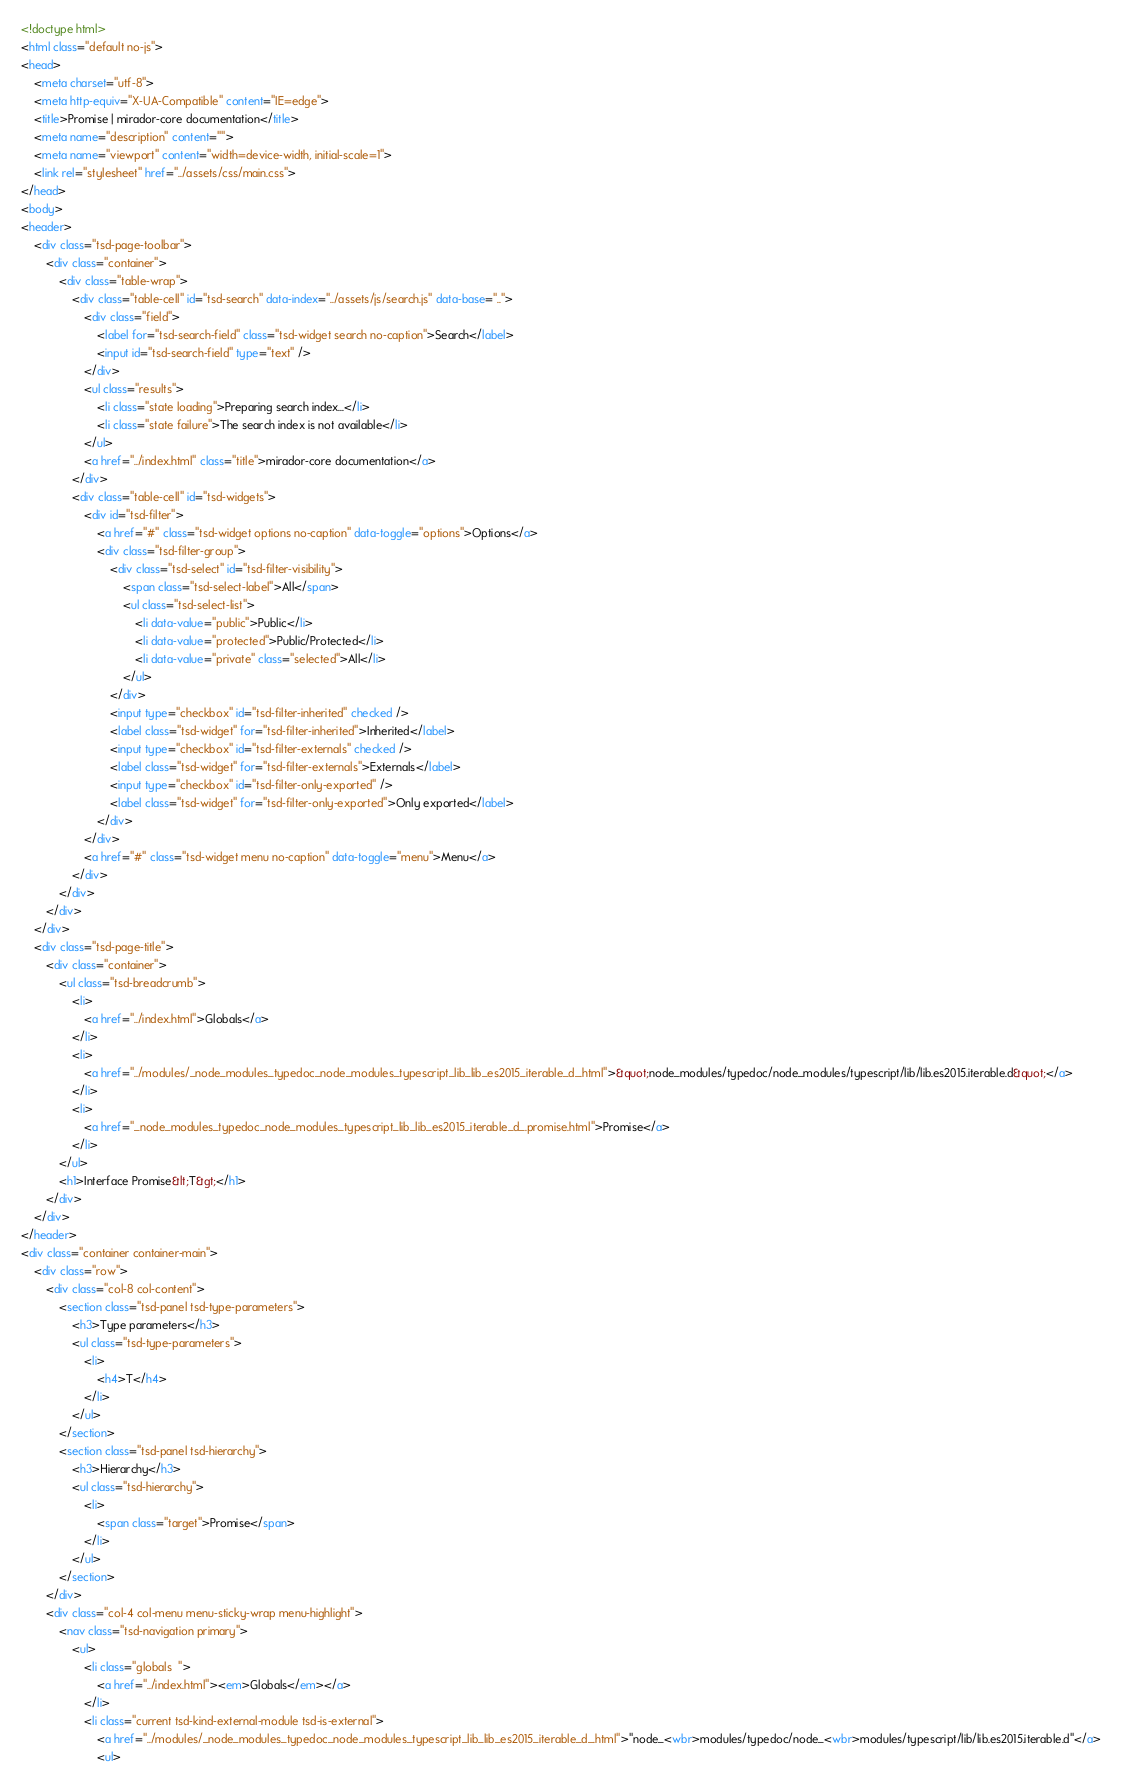Convert code to text. <code><loc_0><loc_0><loc_500><loc_500><_HTML_><!doctype html>
<html class="default no-js">
<head>
	<meta charset="utf-8">
	<meta http-equiv="X-UA-Compatible" content="IE=edge">
	<title>Promise | mirador-core documentation</title>
	<meta name="description" content="">
	<meta name="viewport" content="width=device-width, initial-scale=1">
	<link rel="stylesheet" href="../assets/css/main.css">
</head>
<body>
<header>
	<div class="tsd-page-toolbar">
		<div class="container">
			<div class="table-wrap">
				<div class="table-cell" id="tsd-search" data-index="../assets/js/search.js" data-base="..">
					<div class="field">
						<label for="tsd-search-field" class="tsd-widget search no-caption">Search</label>
						<input id="tsd-search-field" type="text" />
					</div>
					<ul class="results">
						<li class="state loading">Preparing search index...</li>
						<li class="state failure">The search index is not available</li>
					</ul>
					<a href="../index.html" class="title">mirador-core documentation</a>
				</div>
				<div class="table-cell" id="tsd-widgets">
					<div id="tsd-filter">
						<a href="#" class="tsd-widget options no-caption" data-toggle="options">Options</a>
						<div class="tsd-filter-group">
							<div class="tsd-select" id="tsd-filter-visibility">
								<span class="tsd-select-label">All</span>
								<ul class="tsd-select-list">
									<li data-value="public">Public</li>
									<li data-value="protected">Public/Protected</li>
									<li data-value="private" class="selected">All</li>
								</ul>
							</div>
							<input type="checkbox" id="tsd-filter-inherited" checked />
							<label class="tsd-widget" for="tsd-filter-inherited">Inherited</label>
							<input type="checkbox" id="tsd-filter-externals" checked />
							<label class="tsd-widget" for="tsd-filter-externals">Externals</label>
							<input type="checkbox" id="tsd-filter-only-exported" />
							<label class="tsd-widget" for="tsd-filter-only-exported">Only exported</label>
						</div>
					</div>
					<a href="#" class="tsd-widget menu no-caption" data-toggle="menu">Menu</a>
				</div>
			</div>
		</div>
	</div>
	<div class="tsd-page-title">
		<div class="container">
			<ul class="tsd-breadcrumb">
				<li>
					<a href="../index.html">Globals</a>
				</li>
				<li>
					<a href="../modules/_node_modules_typedoc_node_modules_typescript_lib_lib_es2015_iterable_d_.html">&quot;node_modules/typedoc/node_modules/typescript/lib/lib.es2015.iterable.d&quot;</a>
				</li>
				<li>
					<a href="_node_modules_typedoc_node_modules_typescript_lib_lib_es2015_iterable_d_.promise.html">Promise</a>
				</li>
			</ul>
			<h1>Interface Promise&lt;T&gt;</h1>
		</div>
	</div>
</header>
<div class="container container-main">
	<div class="row">
		<div class="col-8 col-content">
			<section class="tsd-panel tsd-type-parameters">
				<h3>Type parameters</h3>
				<ul class="tsd-type-parameters">
					<li>
						<h4>T</h4>
					</li>
				</ul>
			</section>
			<section class="tsd-panel tsd-hierarchy">
				<h3>Hierarchy</h3>
				<ul class="tsd-hierarchy">
					<li>
						<span class="target">Promise</span>
					</li>
				</ul>
			</section>
		</div>
		<div class="col-4 col-menu menu-sticky-wrap menu-highlight">
			<nav class="tsd-navigation primary">
				<ul>
					<li class="globals  ">
						<a href="../index.html"><em>Globals</em></a>
					</li>
					<li class="current tsd-kind-external-module tsd-is-external">
						<a href="../modules/_node_modules_typedoc_node_modules_typescript_lib_lib_es2015_iterable_d_.html">"node_<wbr>modules/typedoc/node_<wbr>modules/typescript/lib/lib.es2015.iterable.d"</a>
						<ul></code> 